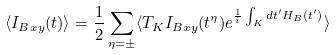<formula> <loc_0><loc_0><loc_500><loc_500>\langle I _ { B x y } ( t ) \rangle = \frac { 1 } { 2 } \sum _ { \eta = \pm } \langle T _ { K } I _ { B x y } ( t ^ { \eta } ) e ^ { \frac { 1 } { i } \int _ { K } d t ^ { \prime } H _ { B } ( t ^ { \prime } ) } \rangle</formula> 